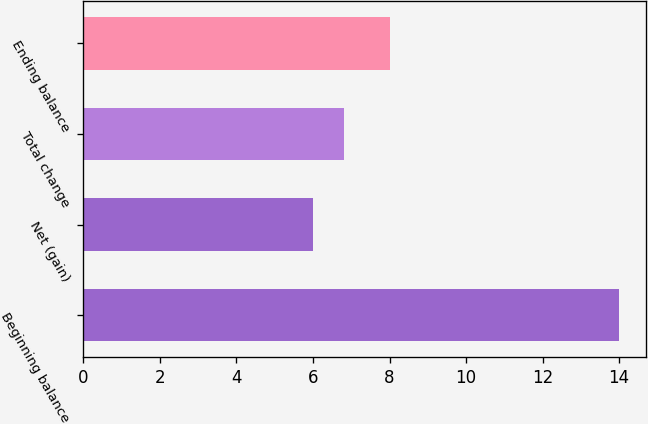Convert chart. <chart><loc_0><loc_0><loc_500><loc_500><bar_chart><fcel>Beginning balance<fcel>Net (gain)<fcel>Total change<fcel>Ending balance<nl><fcel>14<fcel>6<fcel>6.8<fcel>8<nl></chart> 